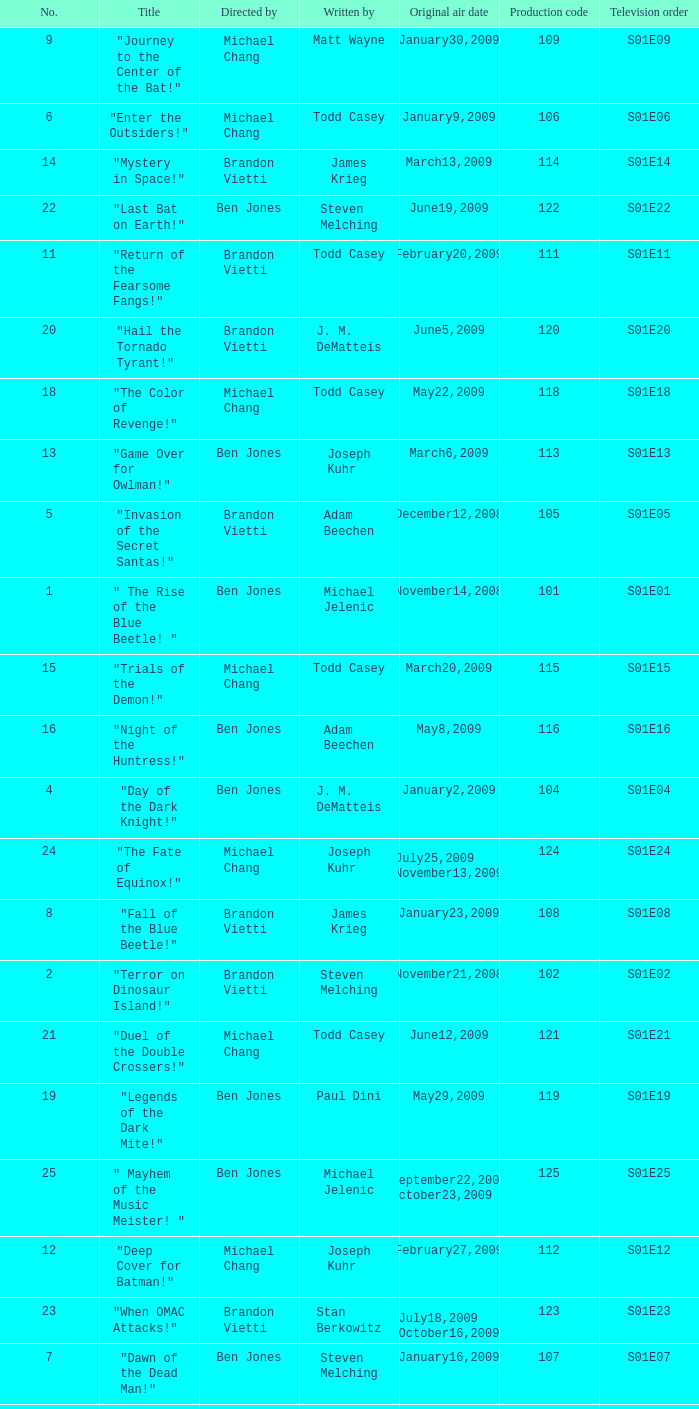Who wrote s01e06 Todd Casey. 